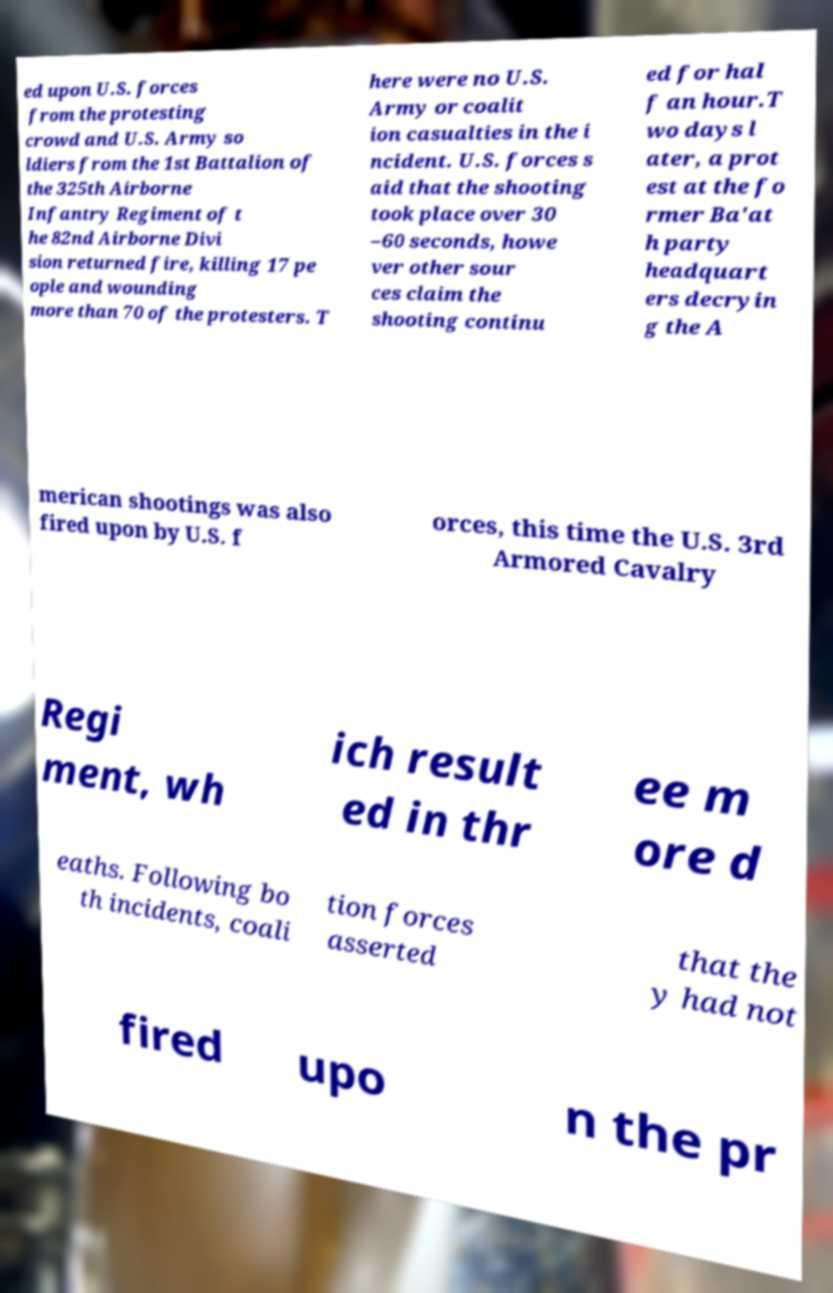Can you read and provide the text displayed in the image?This photo seems to have some interesting text. Can you extract and type it out for me? ed upon U.S. forces from the protesting crowd and U.S. Army so ldiers from the 1st Battalion of the 325th Airborne Infantry Regiment of t he 82nd Airborne Divi sion returned fire, killing 17 pe ople and wounding more than 70 of the protesters. T here were no U.S. Army or coalit ion casualties in the i ncident. U.S. forces s aid that the shooting took place over 30 –60 seconds, howe ver other sour ces claim the shooting continu ed for hal f an hour.T wo days l ater, a prot est at the fo rmer Ba'at h party headquart ers decryin g the A merican shootings was also fired upon by U.S. f orces, this time the U.S. 3rd Armored Cavalry Regi ment, wh ich result ed in thr ee m ore d eaths. Following bo th incidents, coali tion forces asserted that the y had not fired upo n the pr 